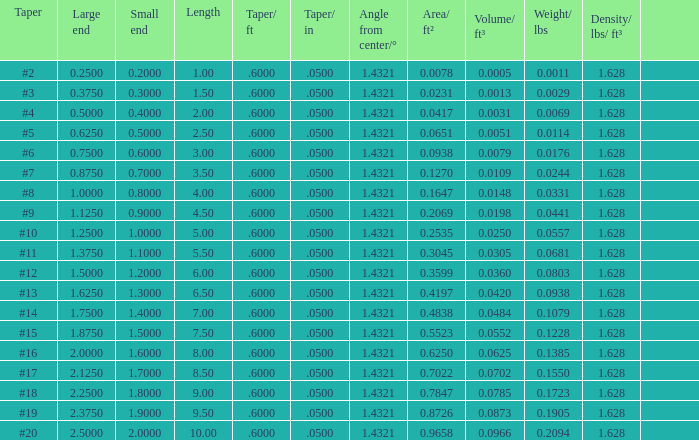Which Taper/in that has a Small end larger than 0.7000000000000001, and a Taper of #19, and a Large end larger than 2.375? None. 